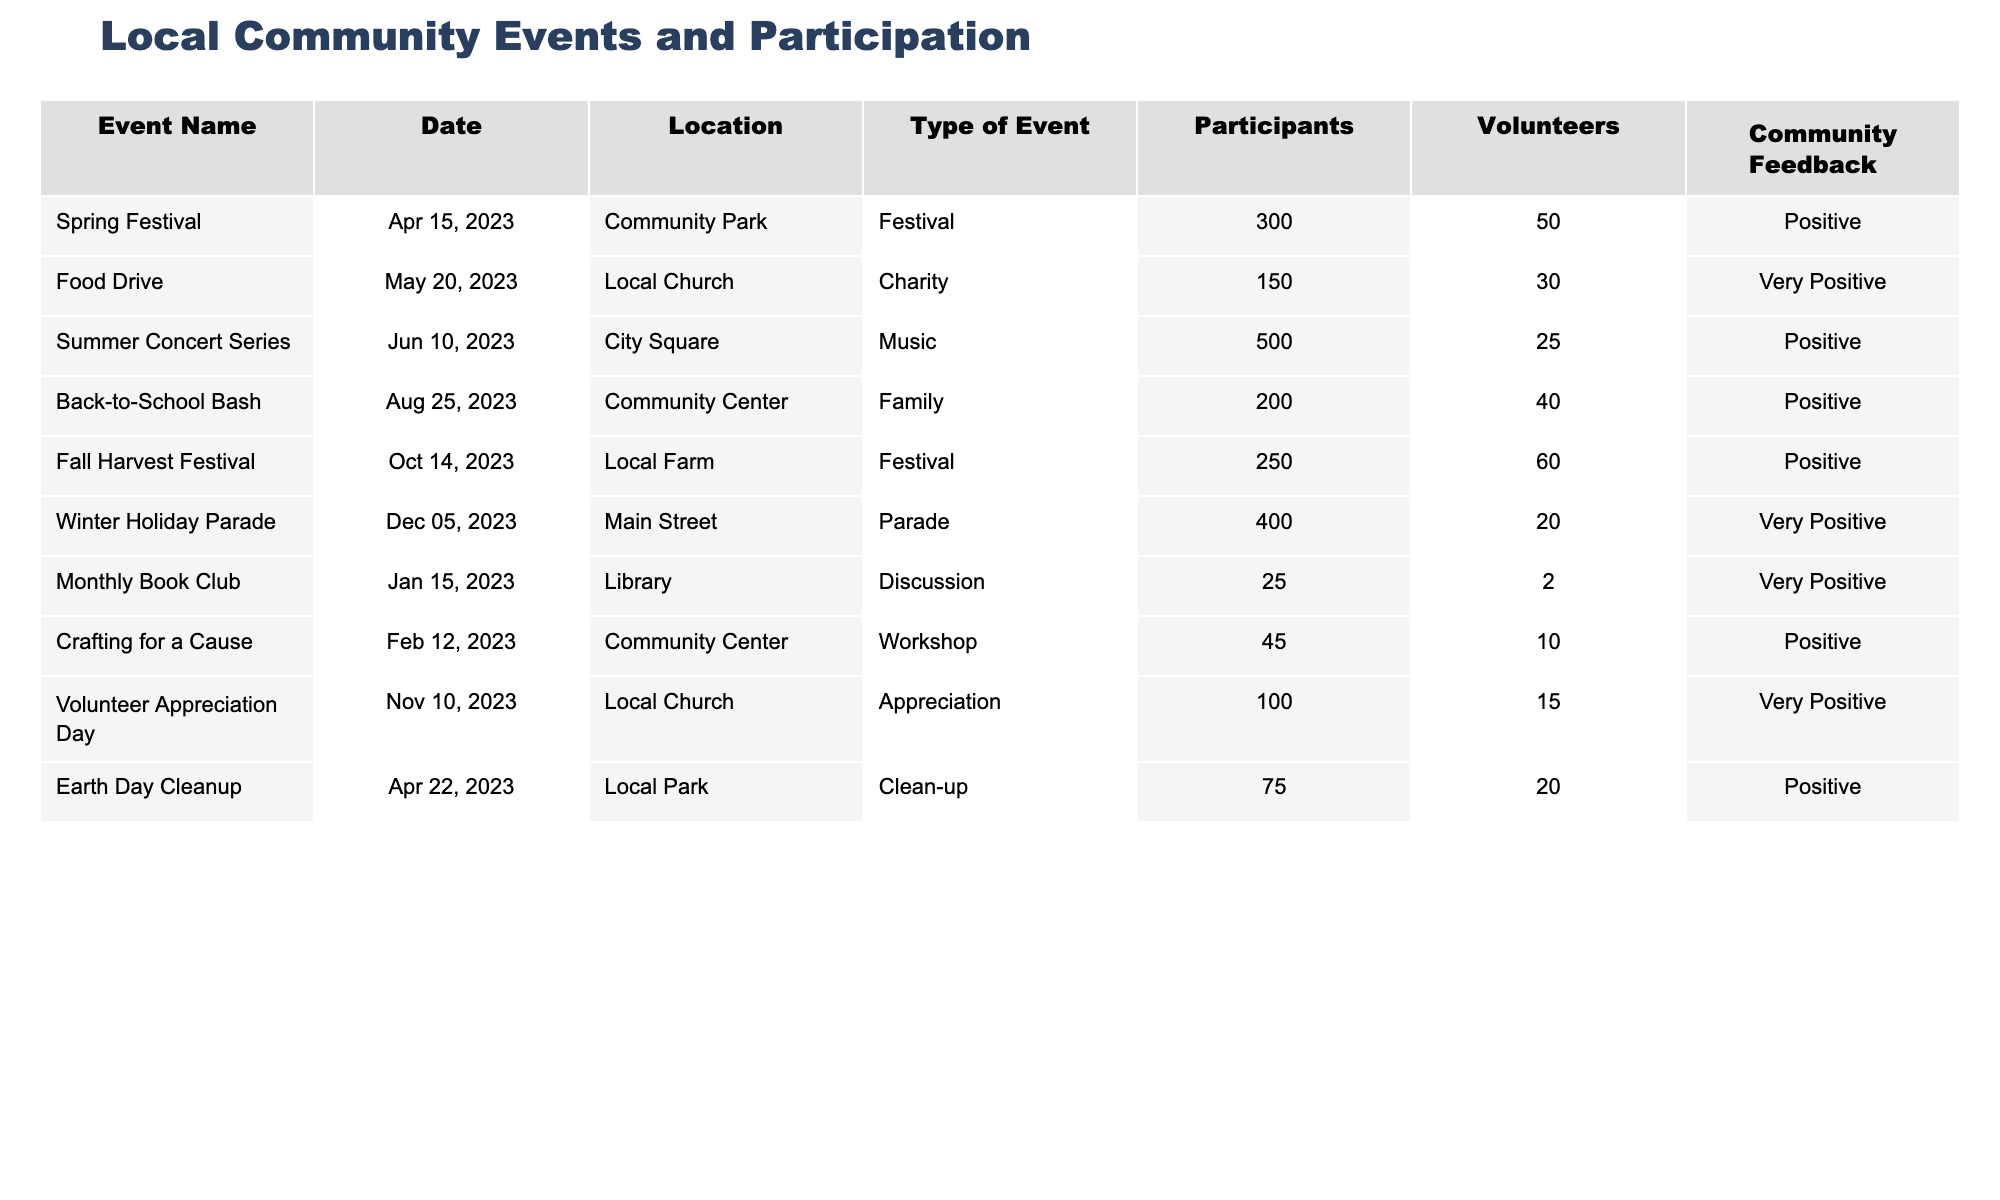What is the total number of participants across all events? To find the total number of participants, I need to sum the values in the "Participants" column: 300 + 150 + 500 + 200 + 250 + 400 + 25 + 45 + 100 + 75 = 2025
Answer: 2025 Which event had the highest number of volunteers? By looking at the "Volunteers" column, I see that the "Fall Harvest Festival" had 60 volunteers, which is the highest compared to other events.
Answer: Fall Harvest Festival Was the feedback for the "Food Drive" positive? The feedback for the "Food Drive" is listed as "Very Positive," which confirms that it was indeed positive.
Answer: Yes How many events took place at the Community Center? I can count the occurrences of "Community Center" in the "Location" column; it appears 2 times, corresponding to the "Back-to-School Bash" and "Crafting for a Cause."
Answer: 2 What is the average number of participants for events classified as "Festival"? The participants for the "Festival" events are 300 (Spring Festival), 250 (Fall Harvest Festival), and 400 (Winter Holiday Parade). Adding them gives 300 + 250 + 400 = 950. Since there are 3 festival events, the average is 950 / 3 = 316.67.
Answer: 316.67 Which event had the least number of participants and how many were there? Checking the "Participants" column, the "Monthly Book Club" had the least number with only 25 participants, compared to all other events.
Answer: 25 How many more volunteers were there at the "Fall Harvest Festival" compared to the "Winter Holiday Parade"? The "Fall Harvest Festival" had 60 volunteers while the "Winter Holiday Parade" had 20 volunteers. The difference is 60 - 20 = 40.
Answer: 40 What percentage of the feedback is classified as "Very Positive"? There are 2 instances of "Very Positive" feedback (Food Drive and Winter Holiday Parade) out of 10 total events. The percentage is (2/10) * 100 = 20%.
Answer: 20% How many events were held in the first half of the year (January to June)? Examining the dates of events, I count 4 events: "Spring Festival," "Food Drive," "Summer Concert Series," and "Monthly Book Club."
Answer: 4 What is the total number of volunteers for all events held at the Local Church? The events held at the Local Church are "Food Drive" with 30 volunteers and "Volunteer Appreciation Day" with 15 volunteers. Therefore, the total is 30 + 15 = 45 volunteers.
Answer: 45 